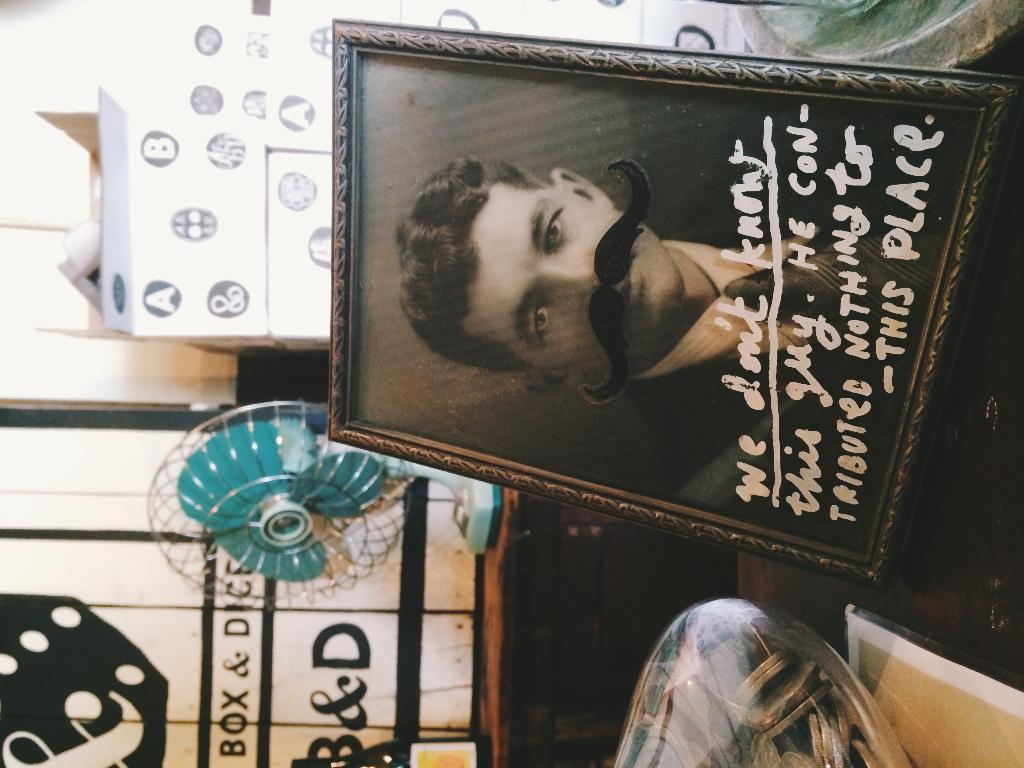What is the main object in the image? There is a frame in the image. What is inside the frame? The frame contains a photograph of a person. Are there any words or letters in the frame? Yes, there is text in the frame. What can be seen in the background of the image? There is a fan and wooden boxes in the background of the image. What type of food can be seen in the image? There is no food present in the image; it features a frame with a photograph and text, along with a fan and wooden boxes in the background. 